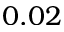<formula> <loc_0><loc_0><loc_500><loc_500>0 . 0 2</formula> 